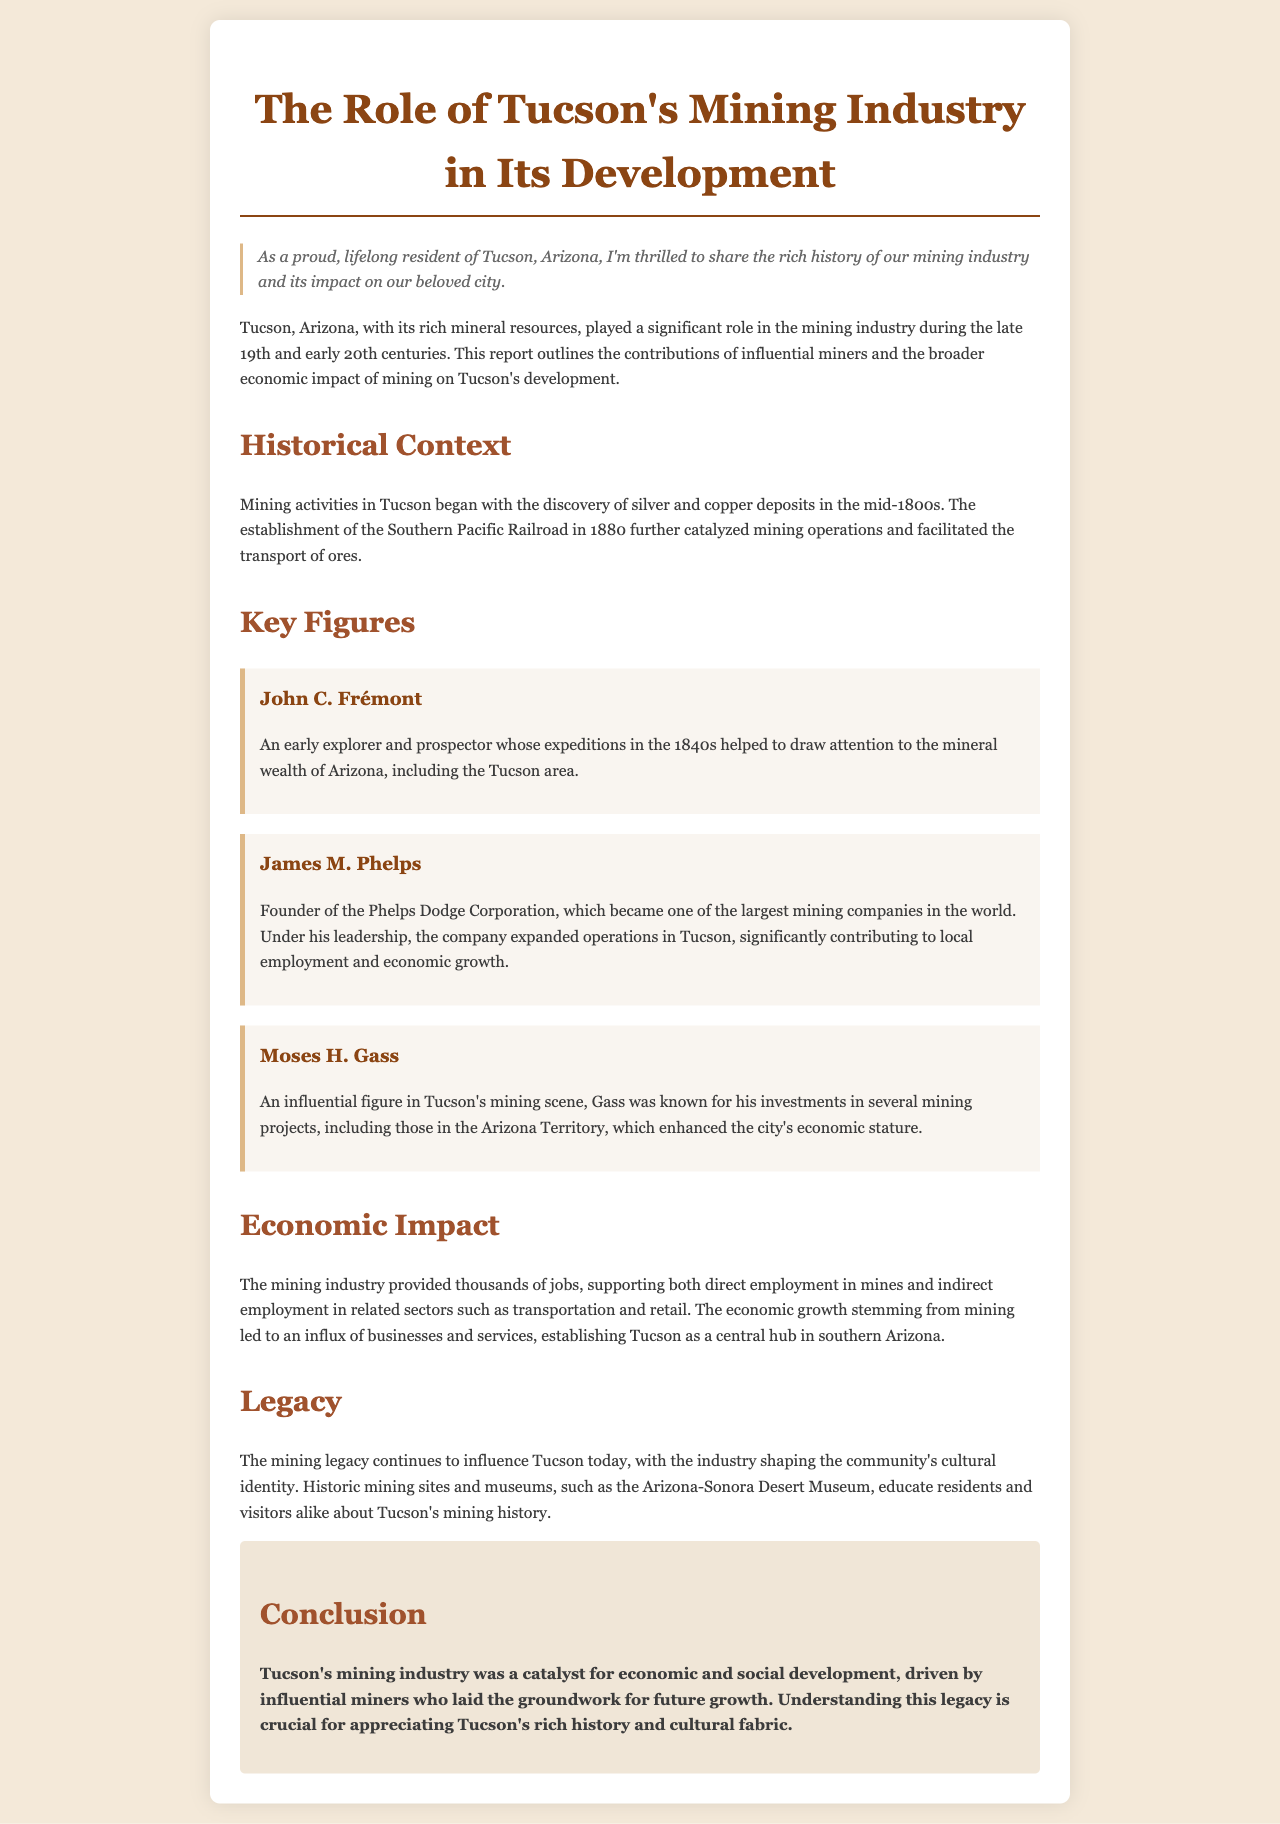What year was the Southern Pacific Railroad established? The document states that the establishment occurred in 1880, which was significant for mining operations in Tucson.
Answer: 1880 Who founded the Phelps Dodge Corporation? The document identifies James M. Phelps as the founder, who played a major role in mining and local economic growth.
Answer: James M. Phelps What was the primary mineral resource mentioned in Tucson during the mid-1800s? The report highlights silver and copper deposits as the main mineral resources discovered at that time.
Answer: Silver and copper Which museum is mentioned as educating about Tucson's mining history? The Arizona-Sonora Desert Museum is recognized in the document for its role in educating residents and visitors.
Answer: Arizona-Sonora Desert Museum What economic contribution did the mining industry provide to Tucson? The document notes that mining provided thousands of jobs and stimulated local business growth in Tucson.
Answer: Thousands of jobs What impact did the mining industry have on employment in Tucson? It indicates that both direct and indirect employment opportunities were created by mining and related sectors.
Answer: Direct and indirect employment Who was an early explorer that highlighted Tucson's mineral wealth? John C. Frémont is mentioned as an influential early explorer connected to Tucson's mining history.
Answer: John C. Frémont What is the overall conclusion about Tucson's mining industry? The conclusion emphasizes that the mining industry was vital for Tucson's economic and social development, impacting its cultural identity.
Answer: Economic and social development 